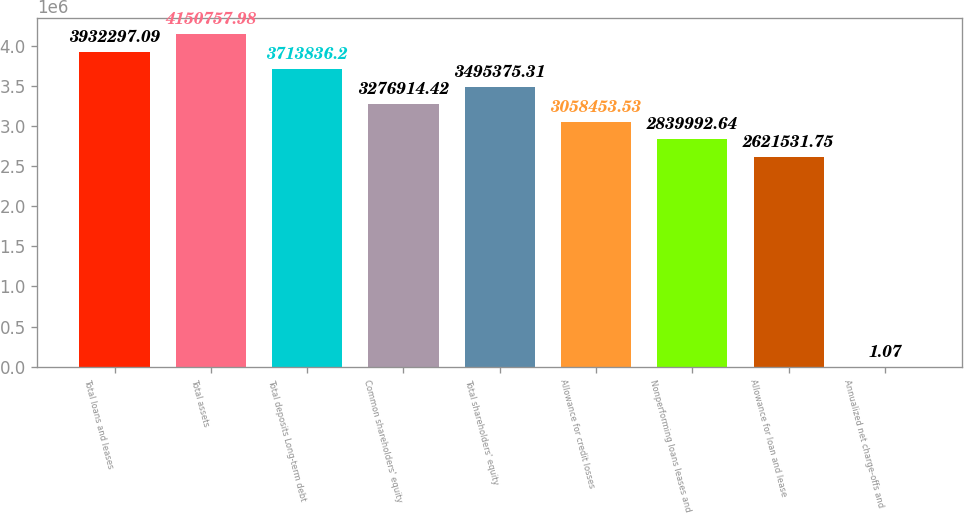Convert chart. <chart><loc_0><loc_0><loc_500><loc_500><bar_chart><fcel>Total loans and leases<fcel>Total assets<fcel>Total deposits Long-term debt<fcel>Common shareholders' equity<fcel>Total shareholders' equity<fcel>Allowance for credit losses<fcel>Nonperforming loans leases and<fcel>Allowance for loan and lease<fcel>Annualized net charge-offs and<nl><fcel>3.9323e+06<fcel>4.15076e+06<fcel>3.71384e+06<fcel>3.27691e+06<fcel>3.49538e+06<fcel>3.05845e+06<fcel>2.83999e+06<fcel>2.62153e+06<fcel>1.07<nl></chart> 